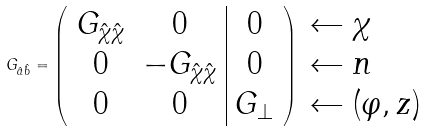<formula> <loc_0><loc_0><loc_500><loc_500>G _ { \hat { a } \hat { b } } = \left ( \begin{array} { c c | c } G _ { \hat { \chi } \hat { \chi } } & 0 & 0 \\ 0 & - G _ { \hat { \chi } \hat { \chi } } & 0 \\ 0 & 0 & G _ { \bot } \end{array} \right ) \begin{array} { l } \leftarrow \chi \\ \leftarrow n \\ \leftarrow ( \varphi , z ) \end{array}</formula> 